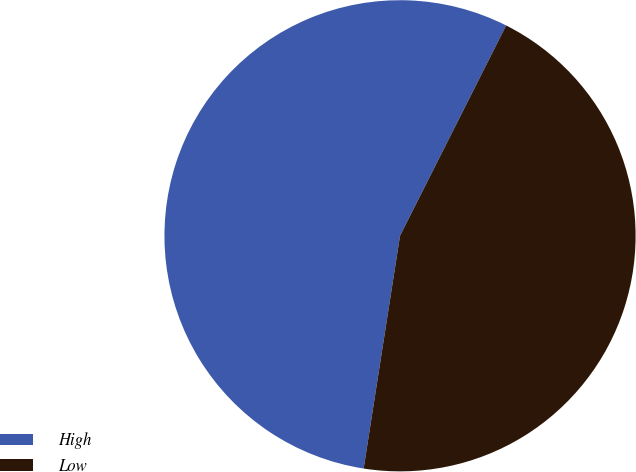<chart> <loc_0><loc_0><loc_500><loc_500><pie_chart><fcel>High<fcel>Low<nl><fcel>54.97%<fcel>45.03%<nl></chart> 